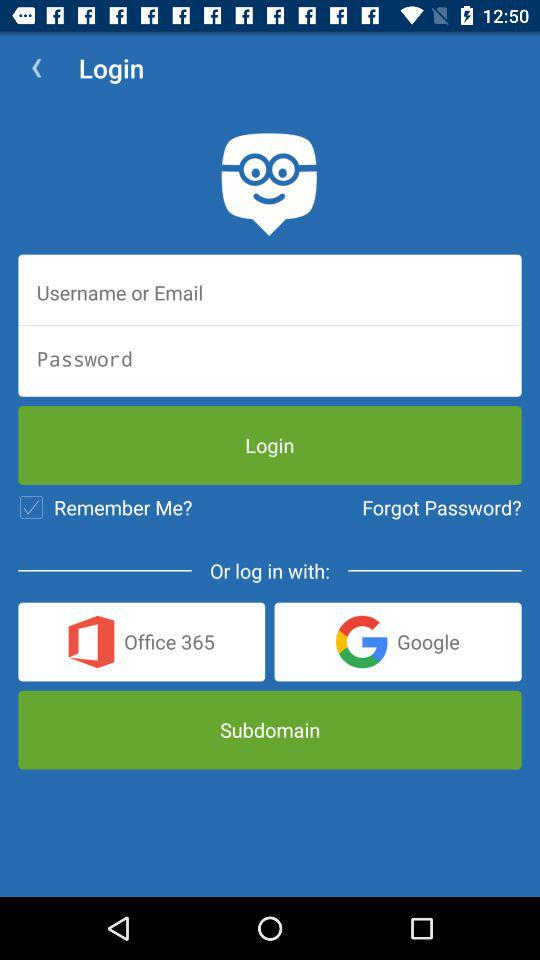What are the different options available for login? The different options available are "Username or Email", "Office 365" and "Google". 